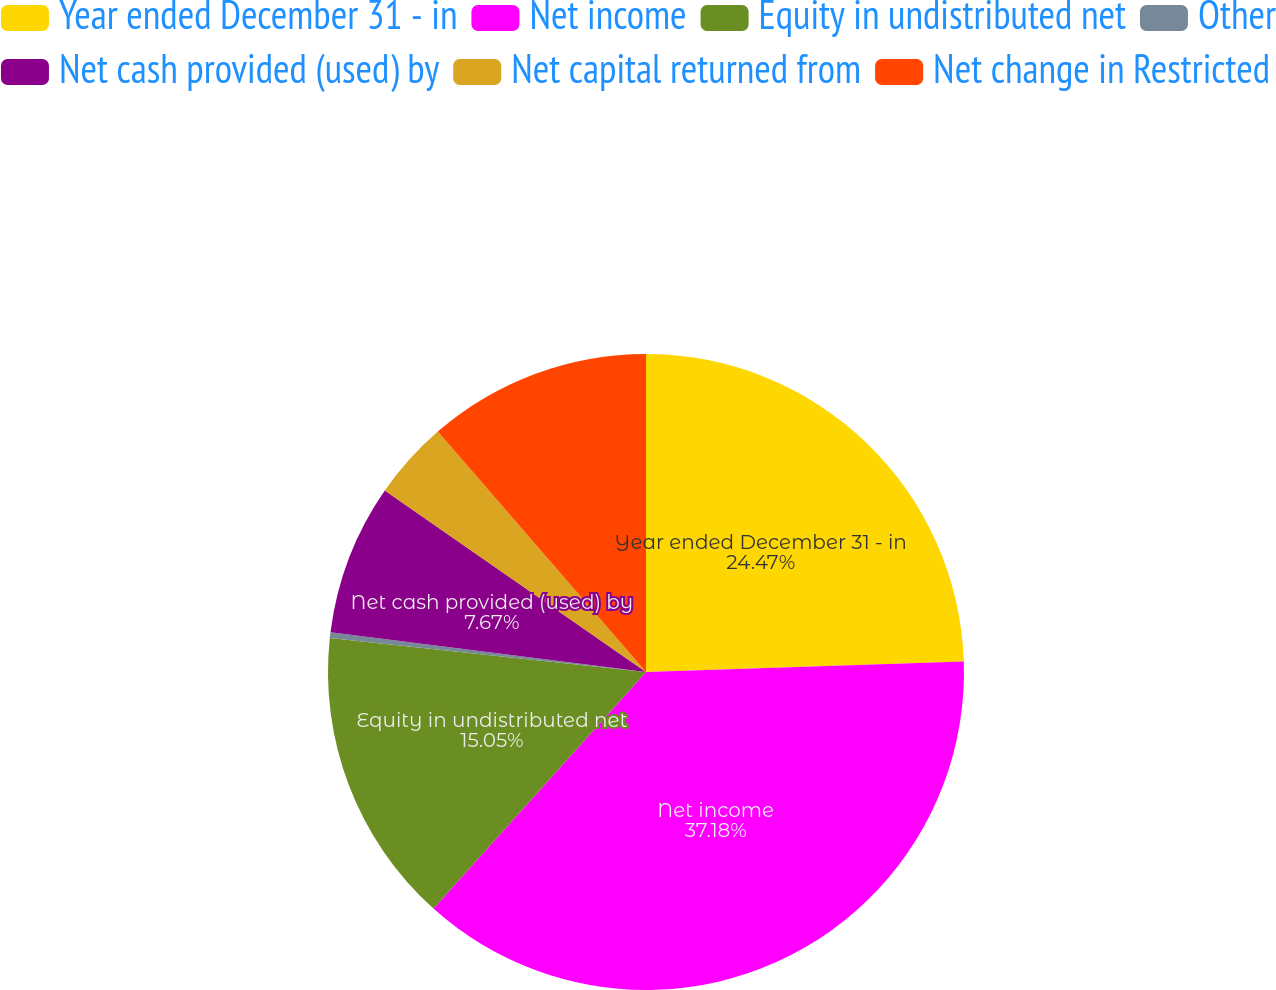<chart> <loc_0><loc_0><loc_500><loc_500><pie_chart><fcel>Year ended December 31 - in<fcel>Net income<fcel>Equity in undistributed net<fcel>Other<fcel>Net cash provided (used) by<fcel>Net capital returned from<fcel>Net change in Restricted<nl><fcel>24.47%<fcel>37.18%<fcel>15.05%<fcel>0.29%<fcel>7.67%<fcel>3.98%<fcel>11.36%<nl></chart> 